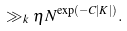Convert formula to latex. <formula><loc_0><loc_0><loc_500><loc_500>\gg _ { k } \eta N ^ { \exp ( - C | K | ) } .</formula> 